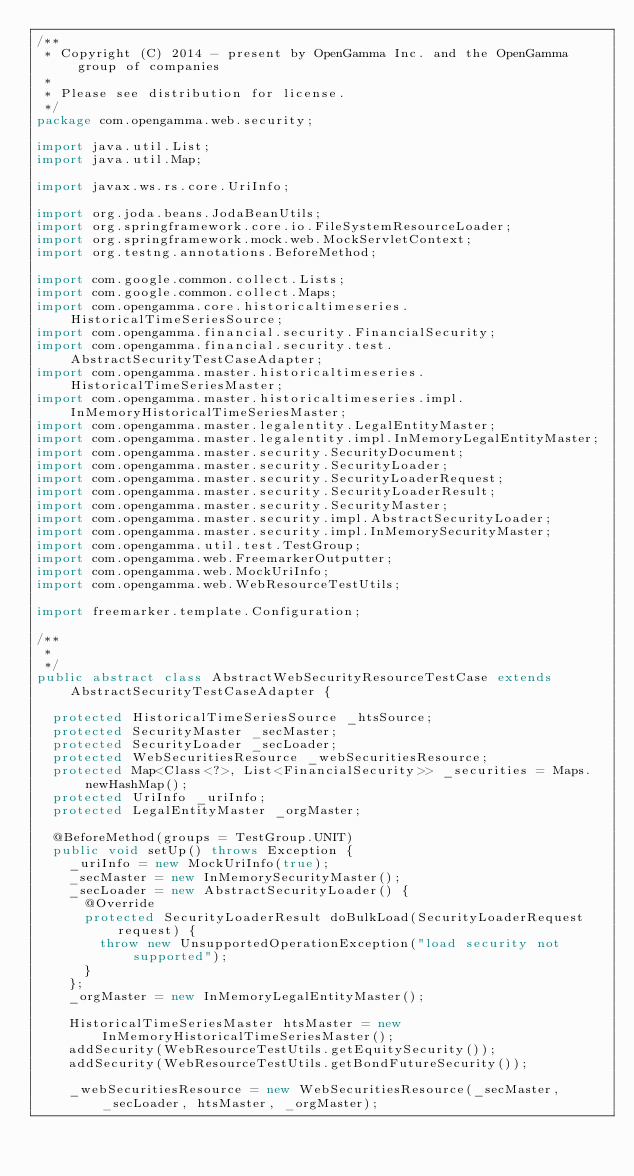<code> <loc_0><loc_0><loc_500><loc_500><_Java_>/**
 * Copyright (C) 2014 - present by OpenGamma Inc. and the OpenGamma group of companies
 * 
 * Please see distribution for license.
 */
package com.opengamma.web.security;

import java.util.List;
import java.util.Map;

import javax.ws.rs.core.UriInfo;

import org.joda.beans.JodaBeanUtils;
import org.springframework.core.io.FileSystemResourceLoader;
import org.springframework.mock.web.MockServletContext;
import org.testng.annotations.BeforeMethod;

import com.google.common.collect.Lists;
import com.google.common.collect.Maps;
import com.opengamma.core.historicaltimeseries.HistoricalTimeSeriesSource;
import com.opengamma.financial.security.FinancialSecurity;
import com.opengamma.financial.security.test.AbstractSecurityTestCaseAdapter;
import com.opengamma.master.historicaltimeseries.HistoricalTimeSeriesMaster;
import com.opengamma.master.historicaltimeseries.impl.InMemoryHistoricalTimeSeriesMaster;
import com.opengamma.master.legalentity.LegalEntityMaster;
import com.opengamma.master.legalentity.impl.InMemoryLegalEntityMaster;
import com.opengamma.master.security.SecurityDocument;
import com.opengamma.master.security.SecurityLoader;
import com.opengamma.master.security.SecurityLoaderRequest;
import com.opengamma.master.security.SecurityLoaderResult;
import com.opengamma.master.security.SecurityMaster;
import com.opengamma.master.security.impl.AbstractSecurityLoader;
import com.opengamma.master.security.impl.InMemorySecurityMaster;
import com.opengamma.util.test.TestGroup;
import com.opengamma.web.FreemarkerOutputter;
import com.opengamma.web.MockUriInfo;
import com.opengamma.web.WebResourceTestUtils;

import freemarker.template.Configuration;

/**
 * 
 */
public abstract class AbstractWebSecurityResourceTestCase extends AbstractSecurityTestCaseAdapter {

  protected HistoricalTimeSeriesSource _htsSource;
  protected SecurityMaster _secMaster;
  protected SecurityLoader _secLoader;
  protected WebSecuritiesResource _webSecuritiesResource;
  protected Map<Class<?>, List<FinancialSecurity>> _securities = Maps.newHashMap();
  protected UriInfo _uriInfo;
  protected LegalEntityMaster _orgMaster;

  @BeforeMethod(groups = TestGroup.UNIT)
  public void setUp() throws Exception {
    _uriInfo = new MockUriInfo(true);
    _secMaster = new InMemorySecurityMaster();
    _secLoader = new AbstractSecurityLoader() {
      @Override
      protected SecurityLoaderResult doBulkLoad(SecurityLoaderRequest request) {
        throw new UnsupportedOperationException("load security not supported");
      }
    };
    _orgMaster = new InMemoryLegalEntityMaster();
    
    HistoricalTimeSeriesMaster htsMaster = new InMemoryHistoricalTimeSeriesMaster();
    addSecurity(WebResourceTestUtils.getEquitySecurity());
    addSecurity(WebResourceTestUtils.getBondFutureSecurity());
        
    _webSecuritiesResource = new WebSecuritiesResource(_secMaster, _secLoader, htsMaster, _orgMaster);</code> 